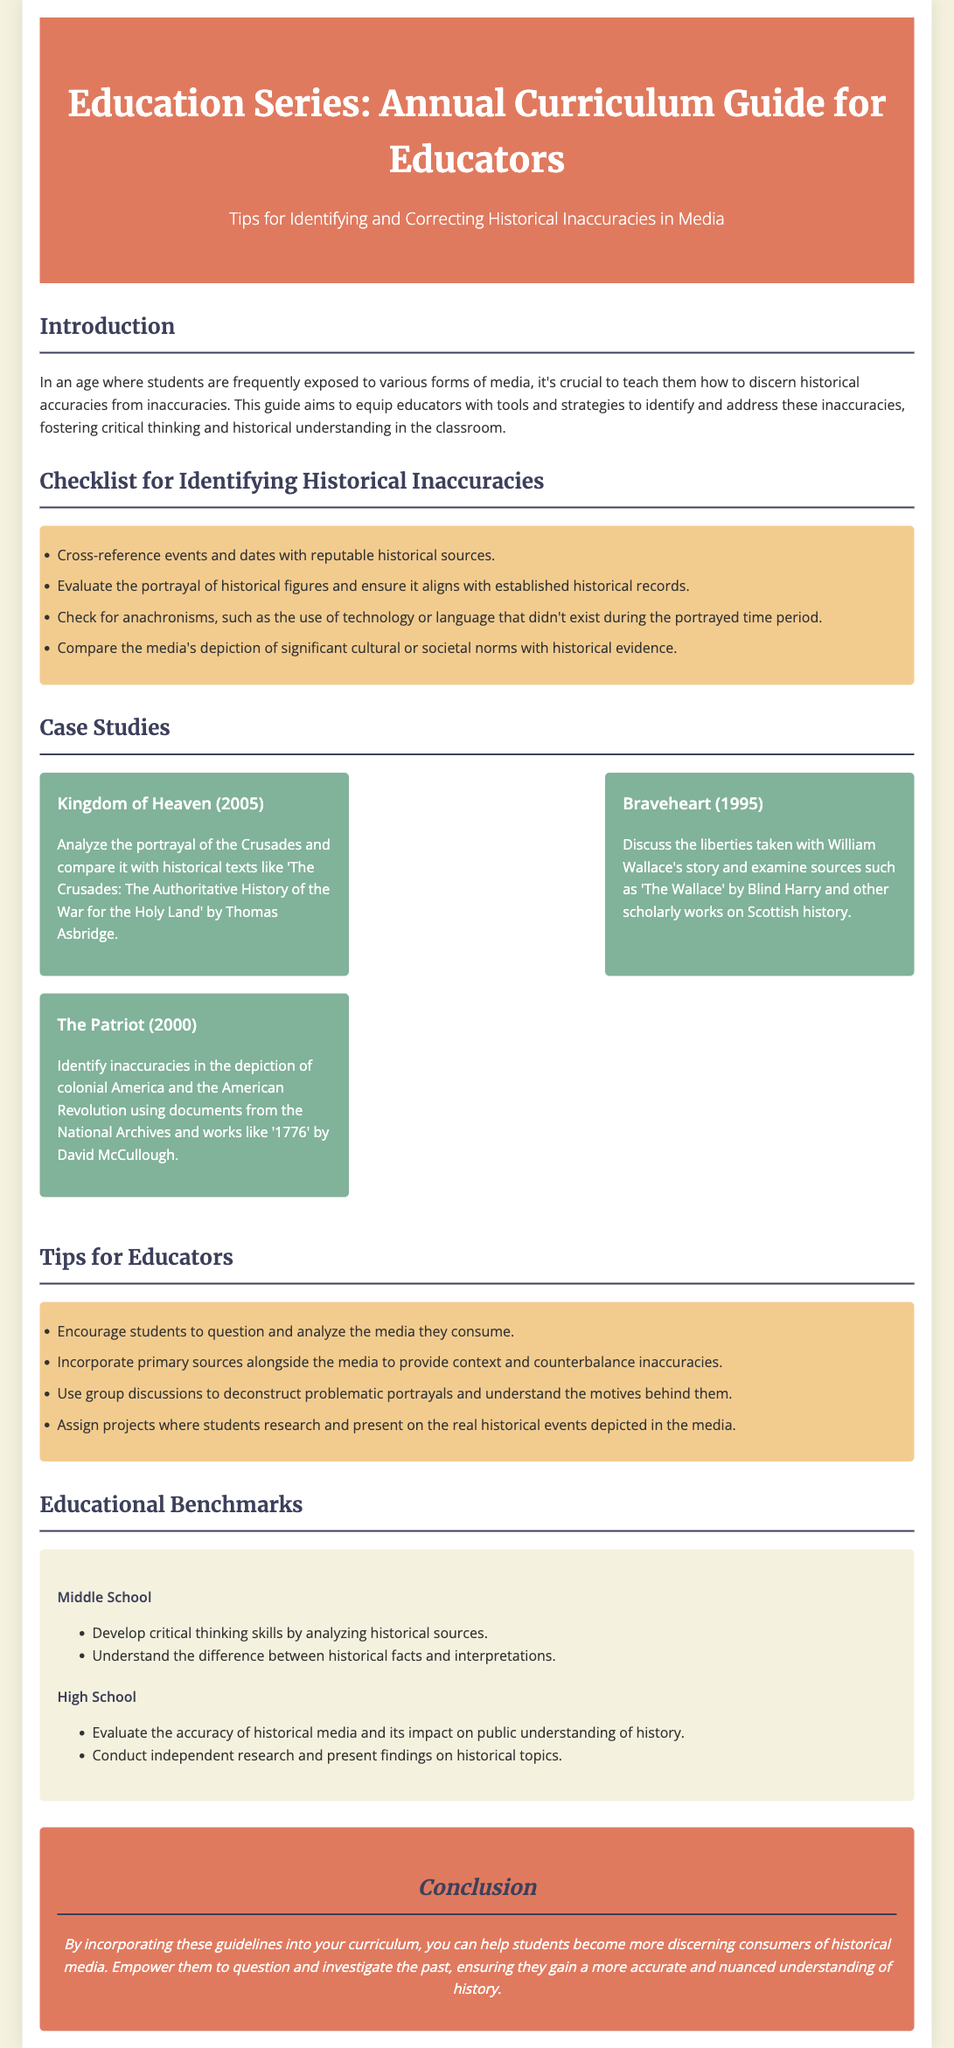what is the title of the document? The title is stated in the header of the document, which is “Education Series: Annual Curriculum Guide for Educators.”
Answer: Education Series: Annual Curriculum Guide for Educators how many case studies are included? The section titled “Case Studies” lists three examples, identifying individual cases in historical media.
Answer: 3 what is the background color of the header? The background color for the header is mentioned in the style section as the color #e07a5f.
Answer: #e07a5f what is a benchmark for high school students? The educational benchmarks for high school detail the expected learning outcomes regarding historical media evaluation.
Answer: Evaluate the accuracy of historical media and its impact on public understanding of history what is one tip for educators provided in the guide? The section on tips for educators provides practical advice to improve teaching.
Answer: Encourage students to question and analyze the media they consume what is the main purpose of the guide? The introduction outlines the purpose, which is to aid educators in teaching students about historical accuracy.
Answer: Equip educators with tools and strategies to identify and address these inaccuracies what are anachronisms? The checklist includes evaluating anachronisms as part of identifying historical inaccuracies, referring to errors in time representation.
Answer: Errors in time representation which case study examines the portrayal of the Crusades? The case studies individually discuss various historical inaccuracies, with one specifically analyzing the Crusades.
Answer: Kingdom of Heaven (2005) what is the color of the checklist section? The checklist section's background color is defined in the style as a specific shade, which is #f2cc8f.
Answer: #f2cc8f 